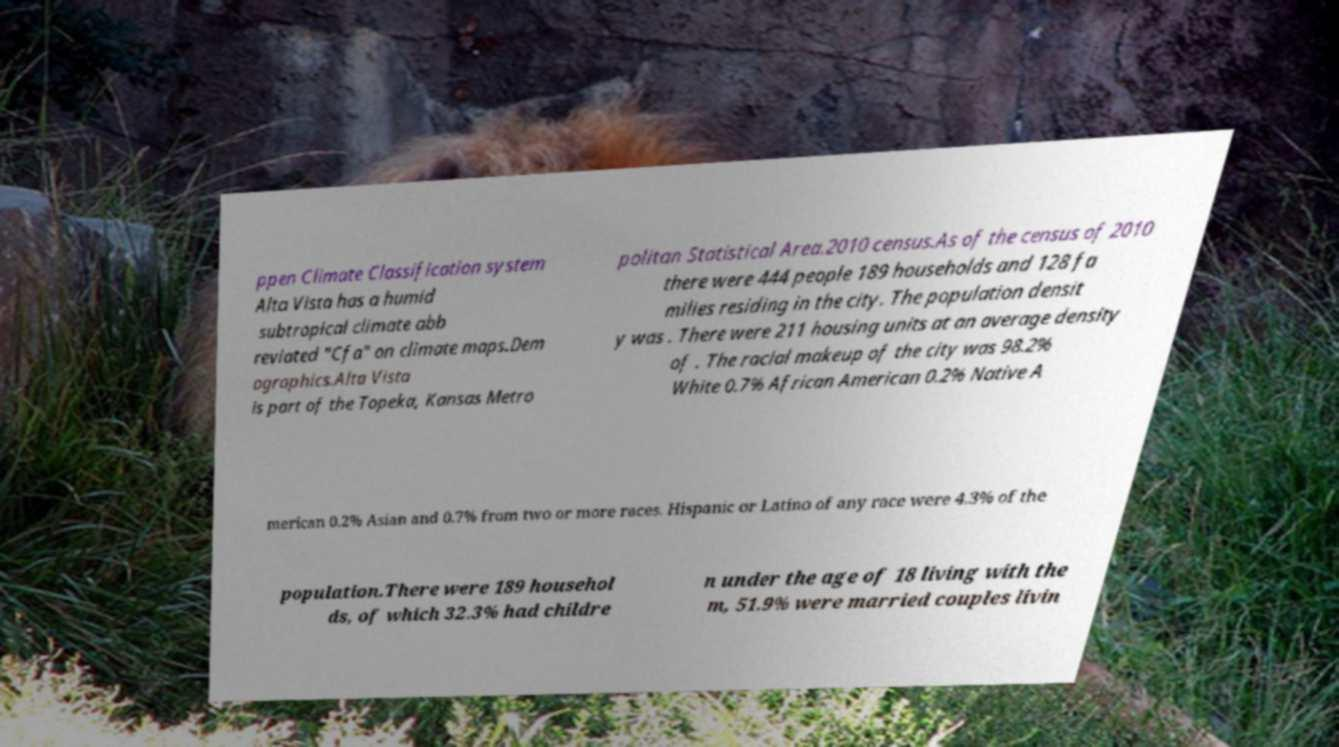There's text embedded in this image that I need extracted. Can you transcribe it verbatim? ppen Climate Classification system Alta Vista has a humid subtropical climate abb reviated "Cfa" on climate maps.Dem ographics.Alta Vista is part of the Topeka, Kansas Metro politan Statistical Area.2010 census.As of the census of 2010 there were 444 people 189 households and 128 fa milies residing in the city. The population densit y was . There were 211 housing units at an average density of . The racial makeup of the city was 98.2% White 0.7% African American 0.2% Native A merican 0.2% Asian and 0.7% from two or more races. Hispanic or Latino of any race were 4.3% of the population.There were 189 househol ds, of which 32.3% had childre n under the age of 18 living with the m, 51.9% were married couples livin 